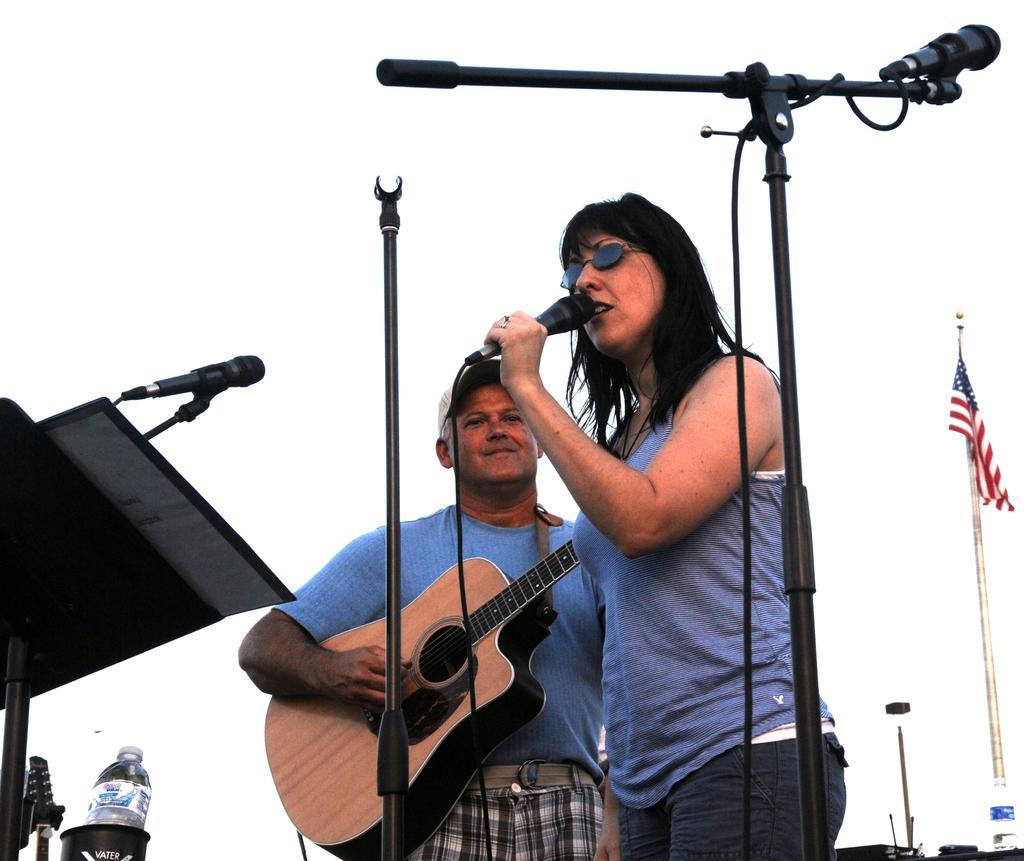Please provide a concise description of this image. In this image we have a woman standing and singing a song in the microphone and at the back ground we have a person standing and playing a guitar a stand , microphone , water bottle, flag attached to the pole. 